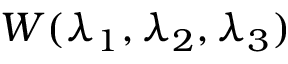Convert formula to latex. <formula><loc_0><loc_0><loc_500><loc_500>W ( \lambda _ { 1 } , \lambda _ { 2 } , \lambda _ { 3 } )</formula> 